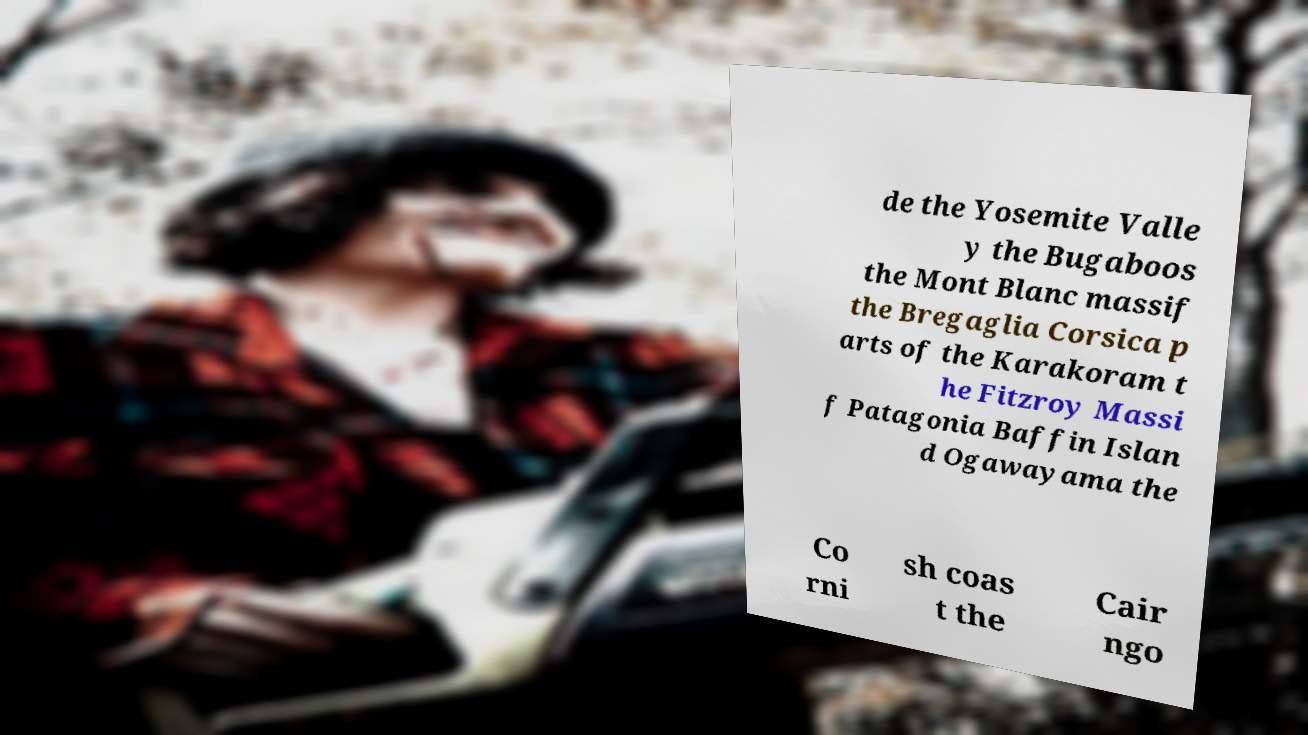Can you read and provide the text displayed in the image?This photo seems to have some interesting text. Can you extract and type it out for me? de the Yosemite Valle y the Bugaboos the Mont Blanc massif the Bregaglia Corsica p arts of the Karakoram t he Fitzroy Massi f Patagonia Baffin Islan d Ogawayama the Co rni sh coas t the Cair ngo 